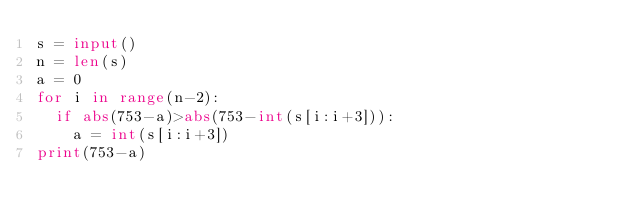Convert code to text. <code><loc_0><loc_0><loc_500><loc_500><_Python_>s = input()
n = len(s)
a = 0
for i in range(n-2):
  if abs(753-a)>abs(753-int(s[i:i+3])):
    a = int(s[i:i+3])
print(753-a)</code> 